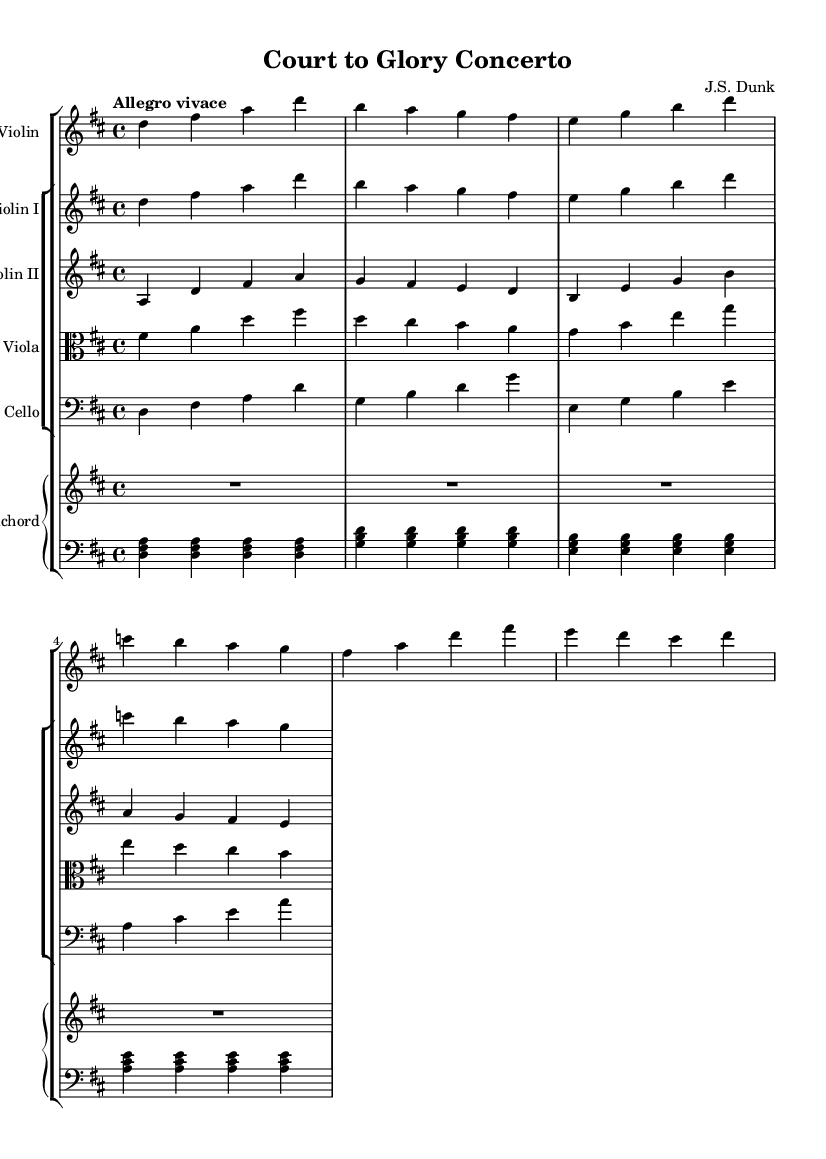What is the key signature of this music? The key signature is indicated by the number of sharps or flats at the beginning of the staff. Looking at the sheet music, there are two sharps, which corresponds to D major.
Answer: D major What is the time signature of this music? The time signature is found at the beginning of the music, typically indicated as a fraction. Here, it shows 4/4, meaning there are four beats per measure and a quarter note gets one beat.
Answer: 4/4 What is the tempo marking of this concerto? The tempo is usually stated above the staff at the beginning of the score. In this case, it is marked "Allegro vivace," indicating a fast and lively pace.
Answer: Allegro vivace How many sections are in the harpsichord part? The harpsichord part is written in two staves, upper and lower, and looking closely, it contains four distinct sections where the notes are played.
Answer: Four sections What instruments are featured in this concerto? By examining the score, one can identify the listed instruments, which include Solo Violin, Violin I, Violin II, Viola, Cello, and Harpsichord.
Answer: Solo Violin, Violin I, Violin II, Viola, Cello, Harpsichord What type of musical form is likely used in this Baroque concerto? While analyzing Baroque concertos, they often utilize a three-movement structure. This can be inferred from the lively character and orchestration of the parts.
Answer: Concerto grosso What is the tonic note in this composition? To find the tonic, look at the key signature which is D major, and the first note of the melody and harmonic progressions in this key would be D.
Answer: D 